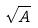<formula> <loc_0><loc_0><loc_500><loc_500>\sqrt { A }</formula> 